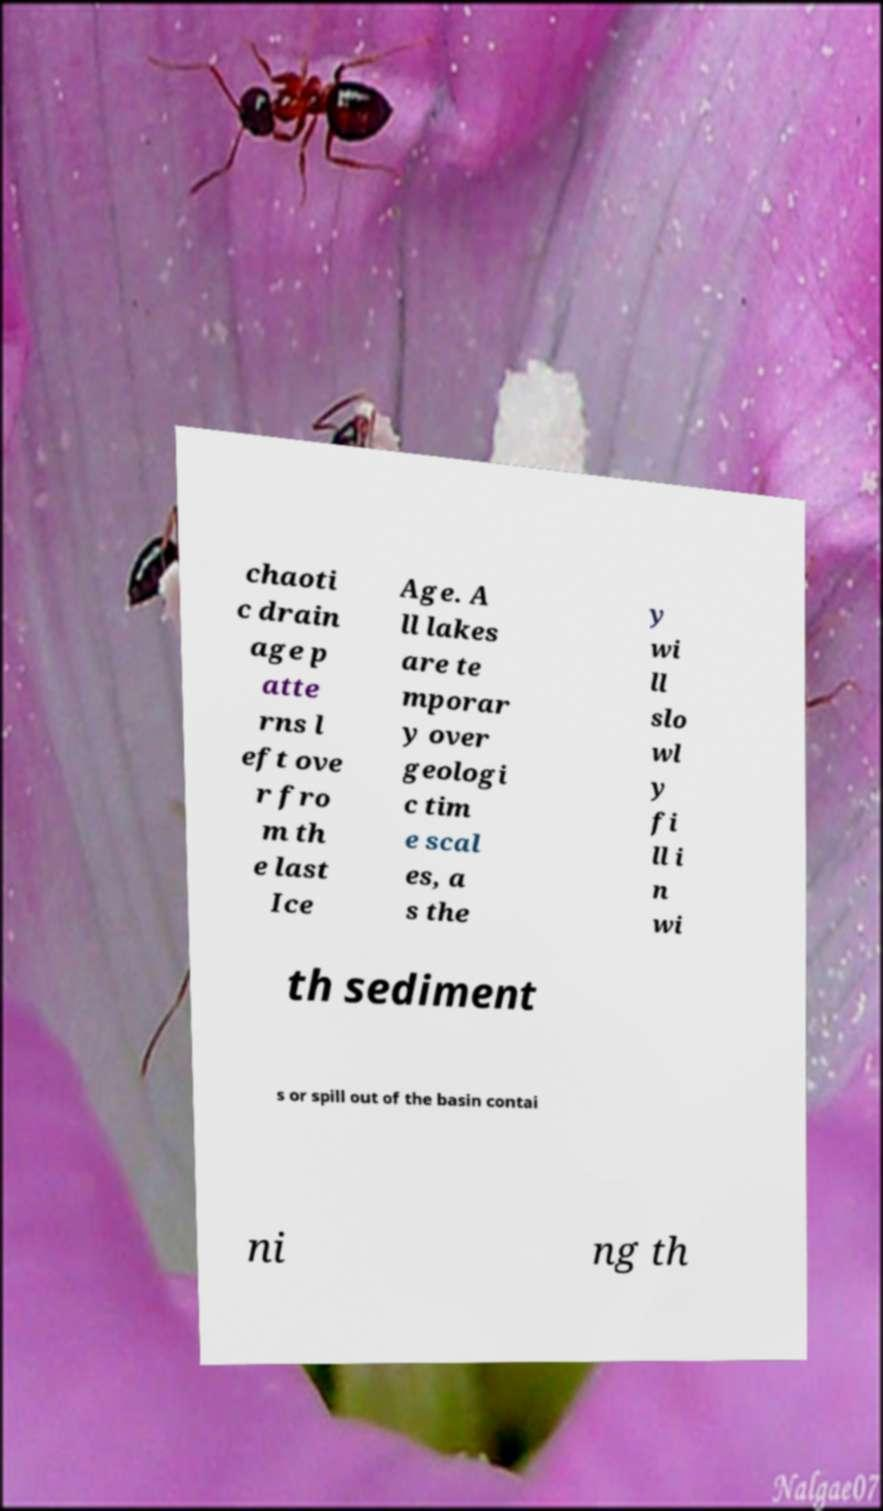What messages or text are displayed in this image? I need them in a readable, typed format. chaoti c drain age p atte rns l eft ove r fro m th e last Ice Age. A ll lakes are te mporar y over geologi c tim e scal es, a s the y wi ll slo wl y fi ll i n wi th sediment s or spill out of the basin contai ni ng th 